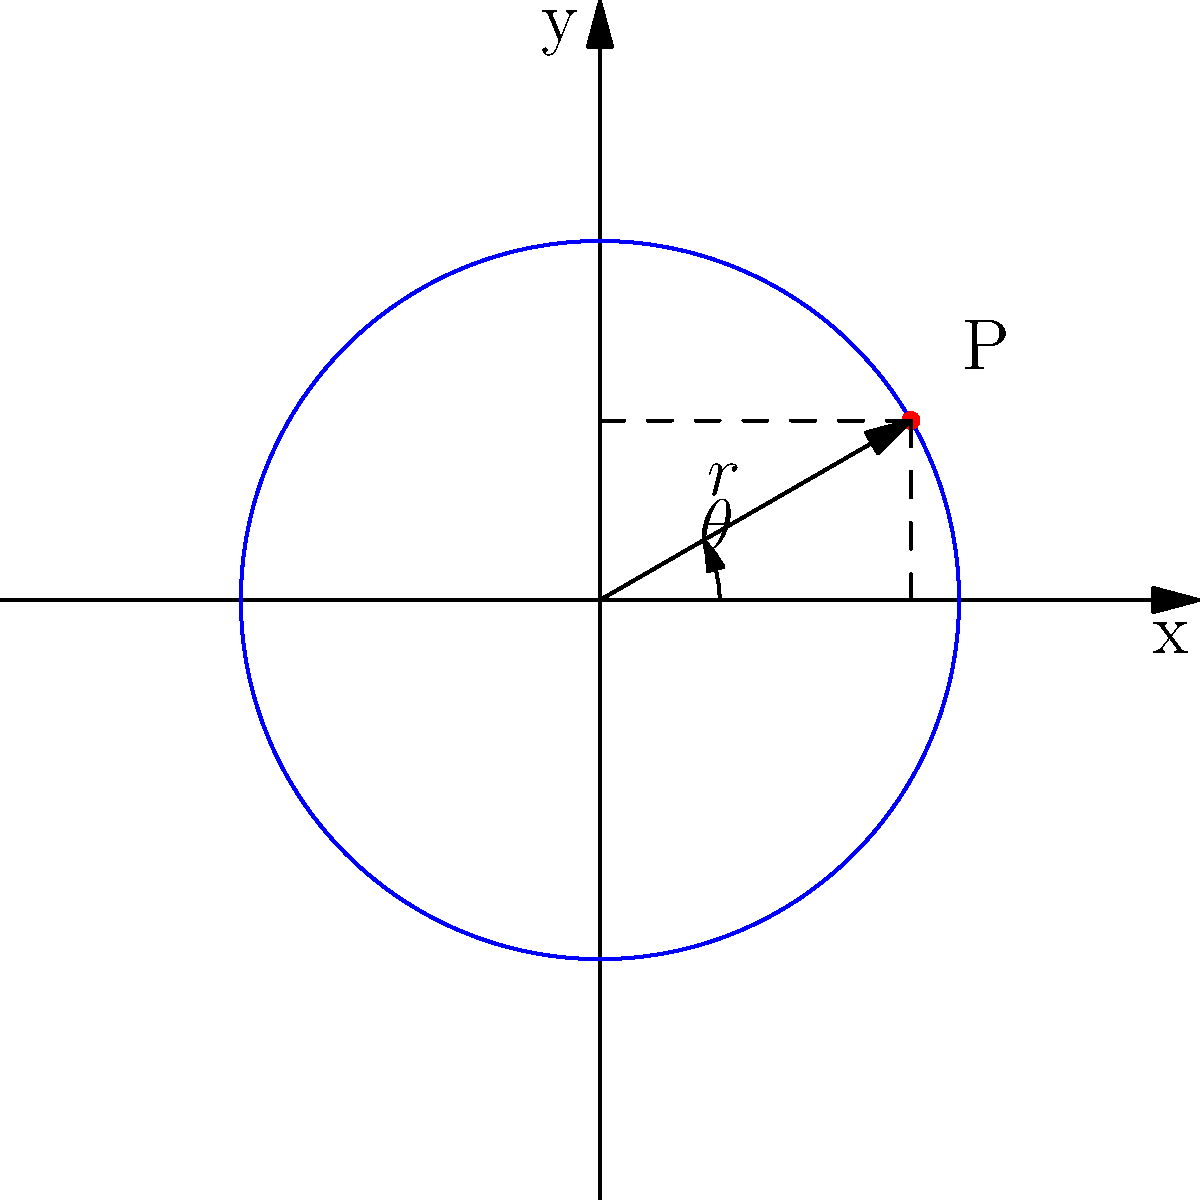In a statistical analysis of circular data, a point P is located on a circle with radius 3 units. Its Cartesian coordinates are $(1.5\sqrt{3}, 1.5)$. What are the polar coordinates $(r, \theta)$ of this point? Express $\theta$ in radians and round your answer to two decimal places. To convert from Cartesian coordinates $(x, y)$ to polar coordinates $(r, \theta)$, we use the following formulas:

1) $r = \sqrt{x^2 + y^2}$
2) $\theta = \arctan(\frac{y}{x})$

Step 1: Calculate r
$r = \sqrt{(1.5\sqrt{3})^2 + 1.5^2}$
$r = \sqrt{6.75 + 2.25}$
$r = \sqrt{9} = 3$

This matches the given radius of the circle.

Step 2: Calculate $\theta$
$\theta = \arctan(\frac{1.5}{1.5\sqrt{3}})$
$\theta = \arctan(\frac{1}{\sqrt{3}})$

We know that $\frac{1}{\sqrt{3}} = \tan(30°)$, so:
$\theta = 30° = \frac{\pi}{6}$ radians $\approx 0.52$ radians

Therefore, the polar coordinates are $(3, 0.52)$.
Answer: $(3, 0.52)$ 